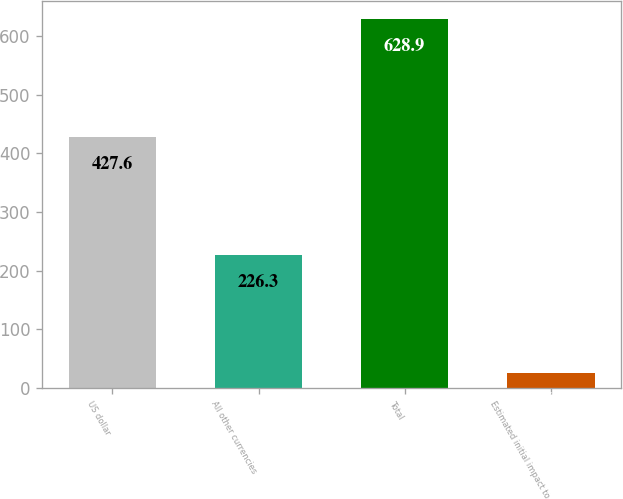Convert chart to OTSL. <chart><loc_0><loc_0><loc_500><loc_500><bar_chart><fcel>US dollar<fcel>All other currencies<fcel>Total<fcel>Estimated initial impact to<nl><fcel>427.6<fcel>226.3<fcel>628.9<fcel>25<nl></chart> 